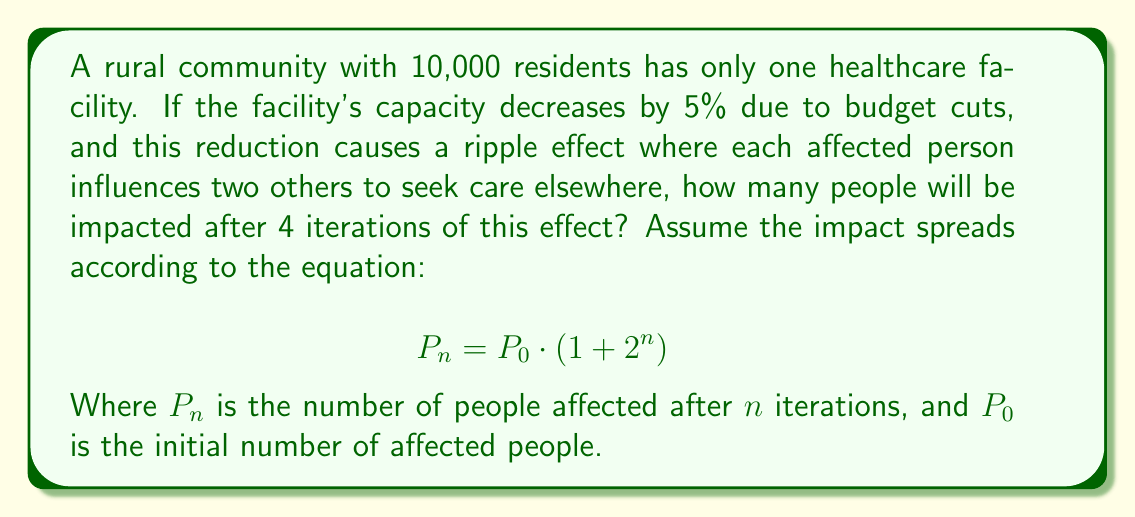Give your solution to this math problem. 1. Calculate the initial number of affected people ($P_0$):
   $5\%$ of 10,000 = $0.05 \times 10,000 = 500$ people

2. Use the given equation to calculate the number of affected people after 4 iterations:
   $$P_4 = P_0 \cdot (1 + 2^4)$$

3. Substitute the values:
   $$P_4 = 500 \cdot (1 + 2^4)$$

4. Calculate $2^4$:
   $$P_4 = 500 \cdot (1 + 16)$$

5. Simplify:
   $$P_4 = 500 \cdot 17$$

6. Calculate the final result:
   $$P_4 = 8,500$$

This demonstrates the butterfly effect in healthcare accessibility, where a small change in one facility's capacity can lead to a significant impact on the community's healthcare-seeking behavior over time.
Answer: 8,500 people 